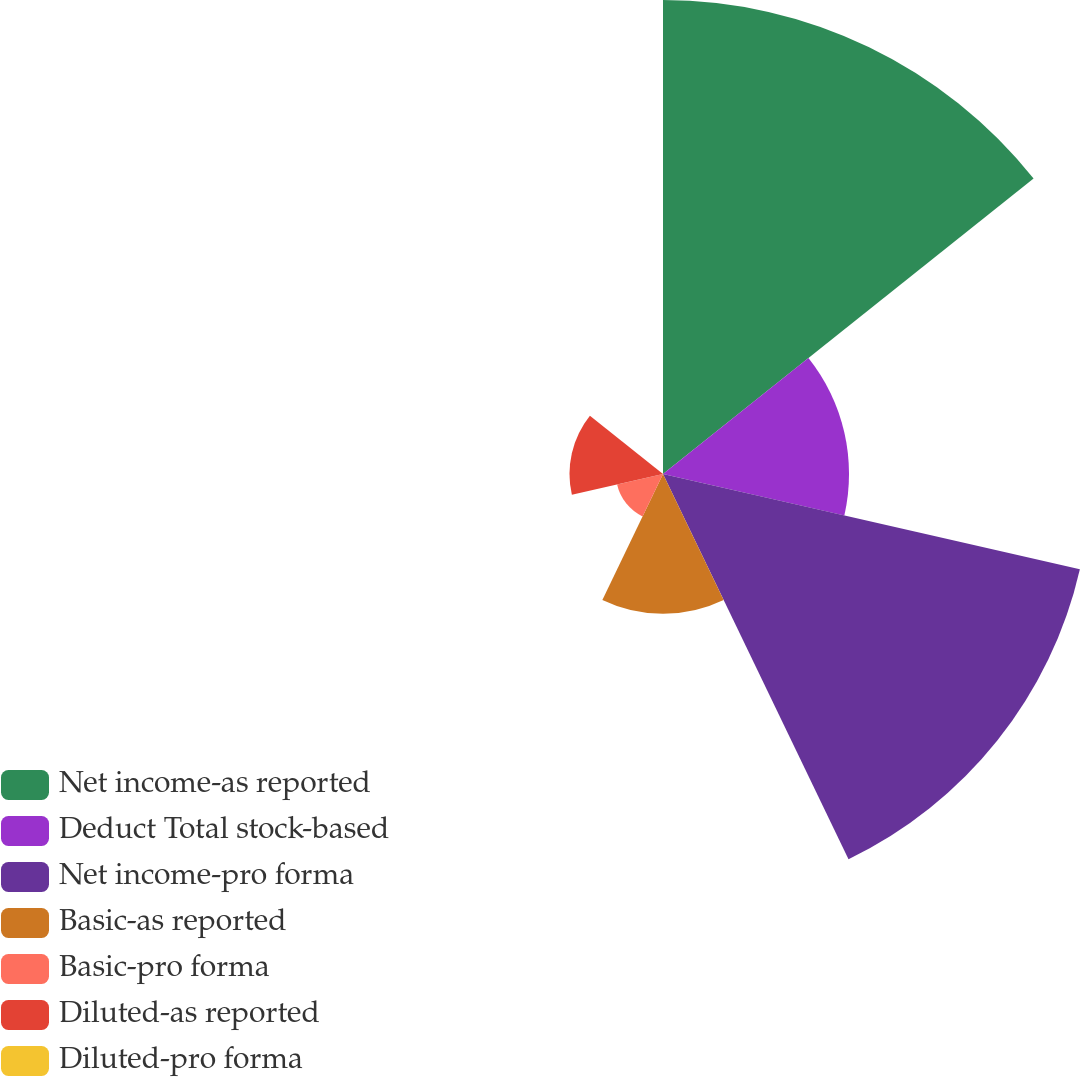Convert chart to OTSL. <chart><loc_0><loc_0><loc_500><loc_500><pie_chart><fcel>Net income-as reported<fcel>Deduct Total stock-based<fcel>Net income-pro forma<fcel>Basic-as reported<fcel>Basic-pro forma<fcel>Diluted-as reported<fcel>Diluted-pro forma<nl><fcel>34.63%<fcel>13.59%<fcel>31.24%<fcel>10.21%<fcel>3.44%<fcel>6.83%<fcel>0.06%<nl></chart> 